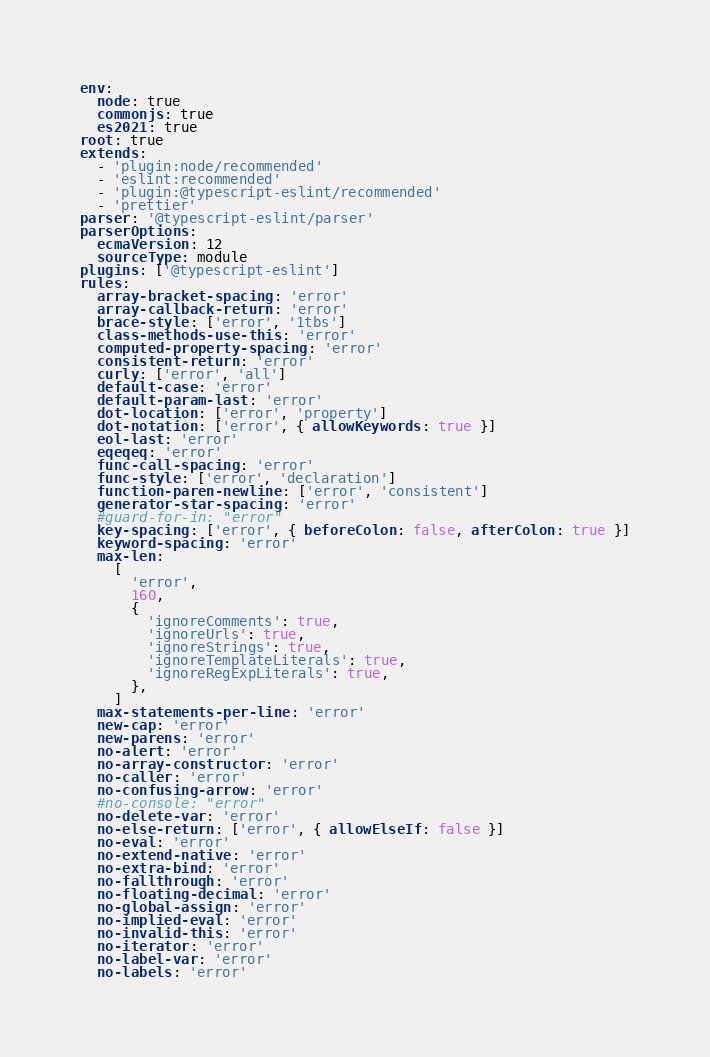Convert code to text. <code><loc_0><loc_0><loc_500><loc_500><_YAML_>env:
  node: true
  commonjs: true
  es2021: true
root: true
extends:
  - 'plugin:node/recommended'
  - 'eslint:recommended'
  - 'plugin:@typescript-eslint/recommended'
  - 'prettier'
parser: '@typescript-eslint/parser'
parserOptions:
  ecmaVersion: 12
  sourceType: module
plugins: ['@typescript-eslint']
rules:
  array-bracket-spacing: 'error'
  array-callback-return: 'error'
  brace-style: ['error', '1tbs']
  class-methods-use-this: 'error'
  computed-property-spacing: 'error'
  consistent-return: 'error'
  curly: ['error', 'all']
  default-case: 'error'
  default-param-last: 'error'
  dot-location: ['error', 'property']
  dot-notation: ['error', { allowKeywords: true }]
  eol-last: 'error'
  eqeqeq: 'error'
  func-call-spacing: 'error'
  func-style: ['error', 'declaration']
  function-paren-newline: ['error', 'consistent']
  generator-star-spacing: 'error'
  #guard-for-in: "error"
  key-spacing: ['error', { beforeColon: false, afterColon: true }]
  keyword-spacing: 'error'
  max-len:
    [
      'error',
      160,
      {
        'ignoreComments': true,
        'ignoreUrls': true,
        'ignoreStrings': true,
        'ignoreTemplateLiterals': true,
        'ignoreRegExpLiterals': true,
      },
    ]
  max-statements-per-line: 'error'
  new-cap: 'error'
  new-parens: 'error'
  no-alert: 'error'
  no-array-constructor: 'error'
  no-caller: 'error'
  no-confusing-arrow: 'error'
  #no-console: "error"
  no-delete-var: 'error'
  no-else-return: ['error', { allowElseIf: false }]
  no-eval: 'error'
  no-extend-native: 'error'
  no-extra-bind: 'error'
  no-fallthrough: 'error'
  no-floating-decimal: 'error'
  no-global-assign: 'error'
  no-implied-eval: 'error'
  no-invalid-this: 'error'
  no-iterator: 'error'
  no-label-var: 'error'
  no-labels: 'error'</code> 